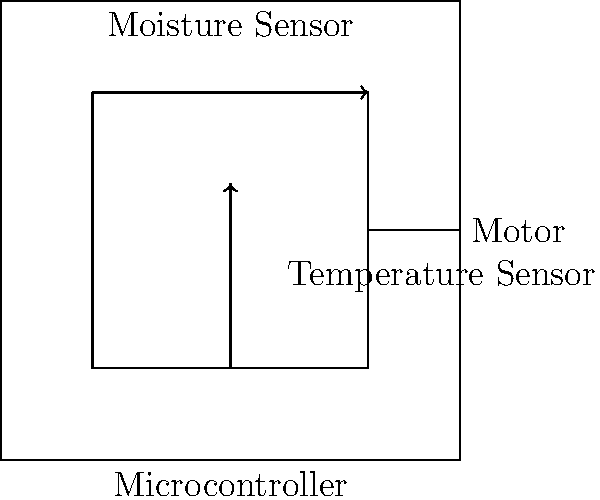In the automated composting system circuit diagram shown above, which component is responsible for processing the sensor data and controlling the motor? To answer this question, let's analyze the components and their connections in the circuit diagram:

1. We can see four main components in the diagram: Moisture Sensor, Temperature Sensor, Microcontroller, and Motor.

2. The Moisture Sensor and Temperature Sensor are connected to the Microcontroller. This indicates that they are sending data to the Microcontroller.

3. The Microcontroller is also connected to the Motor. This suggests that the Microcontroller is controlling the Motor based on some logic or programming.

4. In an automated system, the component that processes input data and makes decisions to control other components is typically a microcontroller or a similar processing unit.

5. The Microcontroller in this diagram is ideally positioned to receive data from both sensors and control the Motor based on that data.

Therefore, the component responsible for processing the sensor data and controlling the motor in this automated composting system is the Microcontroller.
Answer: Microcontroller 